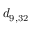<formula> <loc_0><loc_0><loc_500><loc_500>d _ { 9 , 3 2 }</formula> 